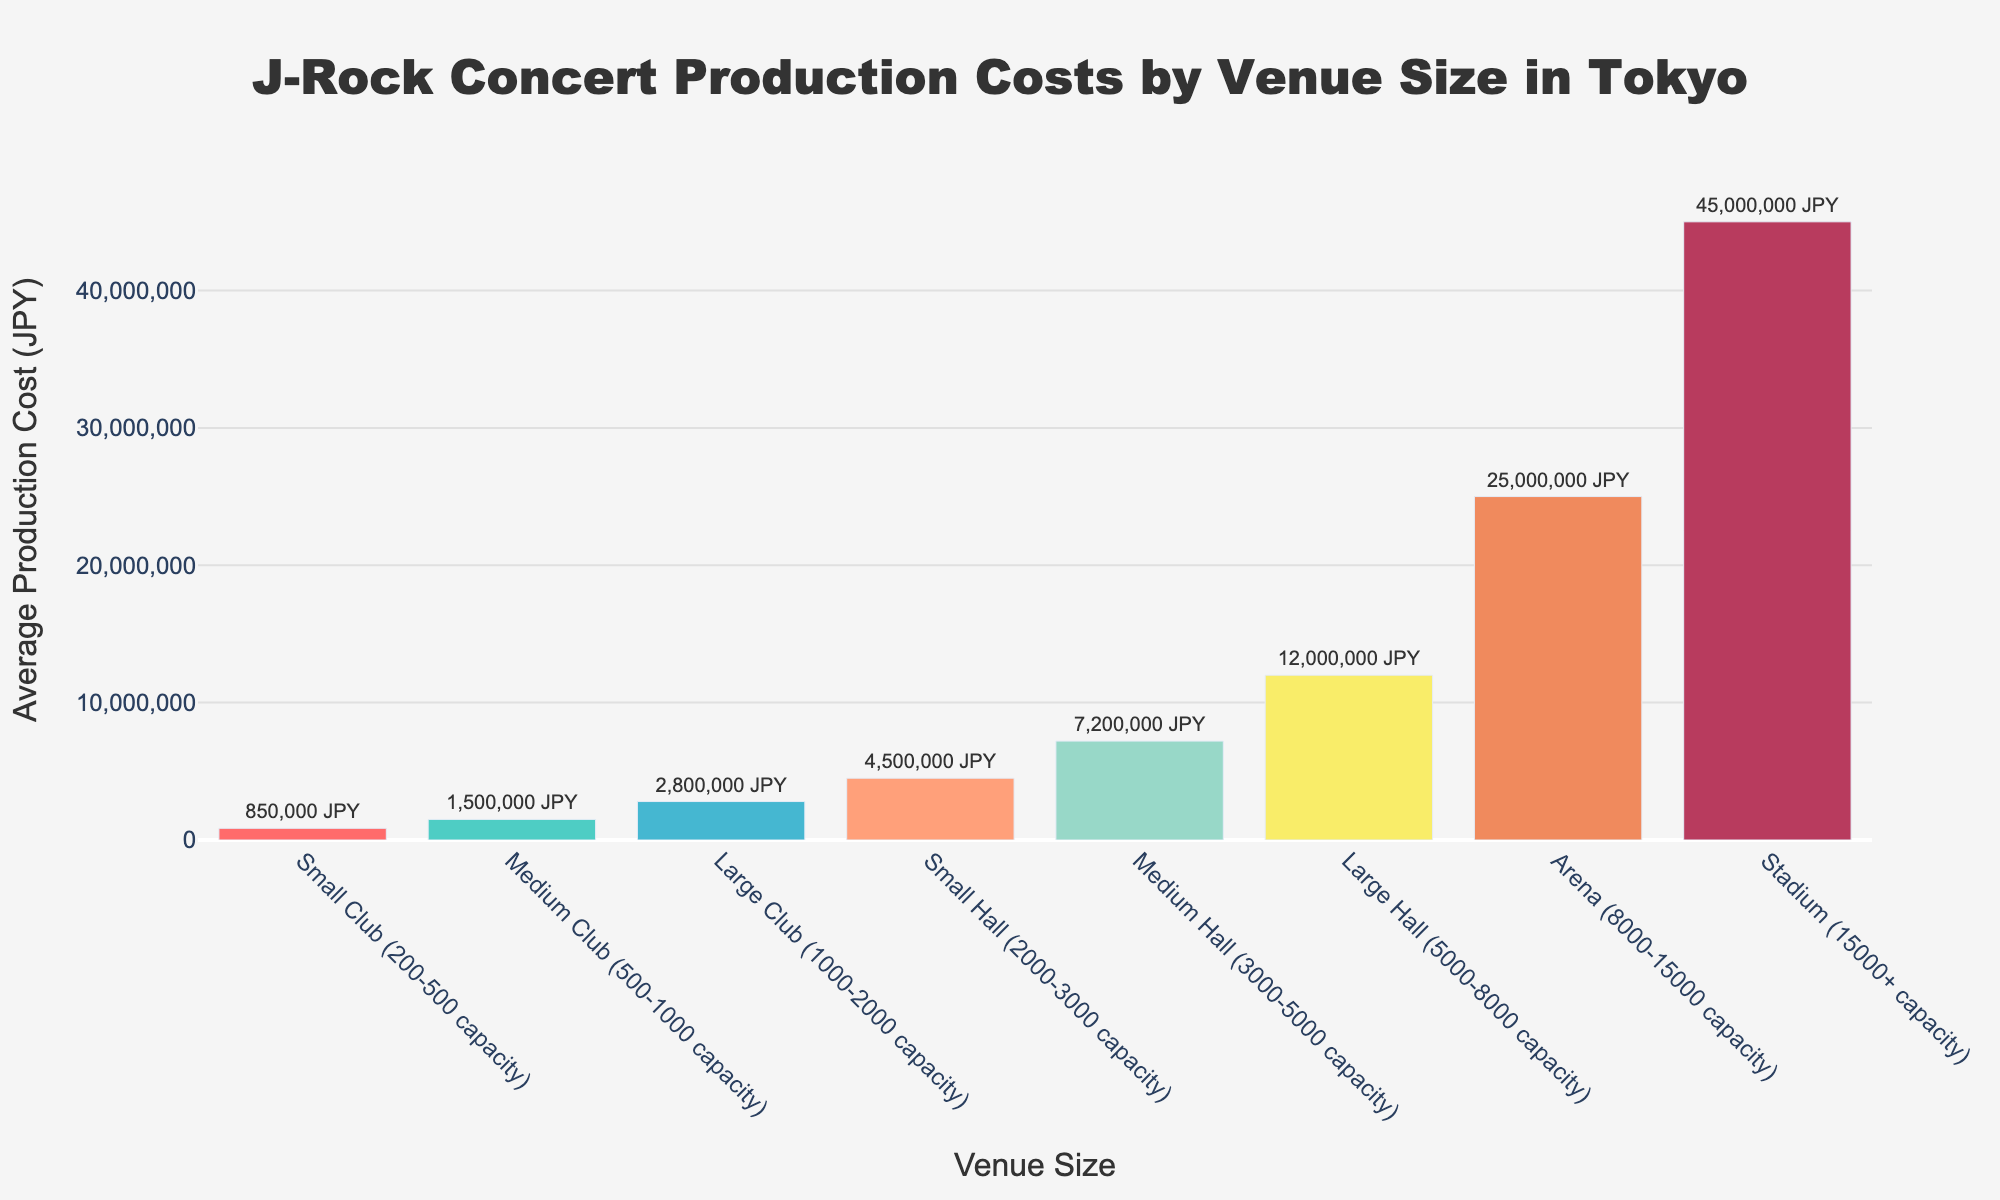Which venue size has the highest production cost? The arena with the highest production cost is identified by the tallest bar in the chart. In this case, the tallest bar corresponds to the "Stadium (15000+ capacity)" which has the highest cost.
Answer: Stadium (15000+ capacity) What is the difference in production cost between the largest and smallest venues? The largest venue is the Stadium (15000+ capacity) with a cost of 45,000,000 JPY. The smallest venue is the Small Club (200-500 capacity) with a cost of 850,000 JPY. The difference is 45,000,000 - 850,000 = 44,150,000 JPY.
Answer: 44,150,000 JPY Which type of venue has a production cost closest to 10,000,000 JPY? To find the venue closest to 10,000,000 JPY, we compare the given costs to 10,000,000 JPY. The Medium Hall (3,000-5,000 capacity) at 7,200,000 JPY is the closest.
Answer: Medium Hall What is the average production cost of all hall venues combined? The hall venues are Small Hall, Medium Hall, and Large Hall, with costs of 4,500,000 JPY, 7,200,000 JPY, and 12,000,000 JPY, respectively. The average cost is (4,500,000 + 7,200,000 + 12,000,000) / 3 = 7,900,000 JPY.
Answer: 7,900,000 JPY Is the production cost for a medium club greater than that for a small hall? The Medium Club (500-1000 capacity) has a production cost of 1,500,000 JPY, and the Small Hall (2000-3000 capacity) has a production cost of 4,500,000 JPY. Comparing the two, the Small Hall has a higher production cost.
Answer: No How much more does it cost to produce a concert in a large club compared to a small club? The Large Club (1000-2000 capacity) costs 2,800,000 JPY, and the Small Club (200-500 capacity) costs 850,000 JPY. The additional cost is 2,800,000 - 850,000 = 1,950,000 JPY.
Answer: 1,950,000 JPY What is the combined production cost of medium and large clubs? The Medium Club (500-1000 capacity) costs 1,500,000 JPY and the Large Club (1000-2000 capacity) costs 2,800,000 JPY. Their combined cost is 1,500,000 + 2,800,000 = 4,300,000 JPY.
Answer: 4,300,000 JPY Which venue size has the second-highest production cost? To find the second-highest production cost, we identify the two tallest bars and take the one with the second tallest height. The tallest cost is 45,000,000 JPY (Stadium), and the second tallest is 25,000,000 JPY (Arena).
Answer: Arena 